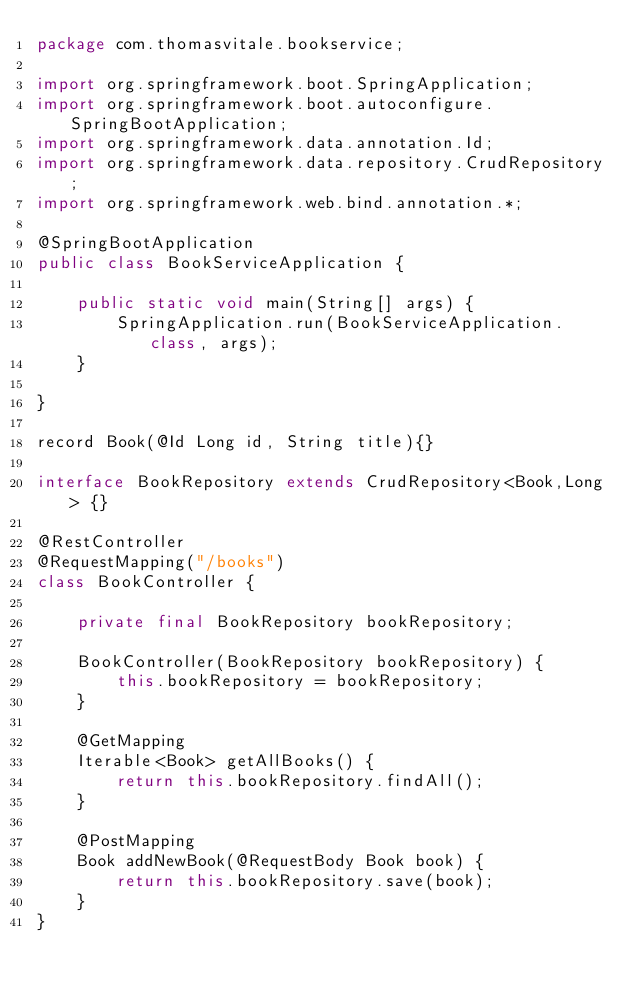<code> <loc_0><loc_0><loc_500><loc_500><_Java_>package com.thomasvitale.bookservice;

import org.springframework.boot.SpringApplication;
import org.springframework.boot.autoconfigure.SpringBootApplication;
import org.springframework.data.annotation.Id;
import org.springframework.data.repository.CrudRepository;
import org.springframework.web.bind.annotation.*;

@SpringBootApplication
public class BookServiceApplication {

    public static void main(String[] args) {
        SpringApplication.run(BookServiceApplication.class, args);
    }

}

record Book(@Id Long id, String title){}

interface BookRepository extends CrudRepository<Book,Long> {}

@RestController
@RequestMapping("/books")
class BookController {

    private final BookRepository bookRepository;

    BookController(BookRepository bookRepository) {
        this.bookRepository = bookRepository;
    }

    @GetMapping
    Iterable<Book> getAllBooks() {
        return this.bookRepository.findAll();
    }

    @PostMapping
    Book addNewBook(@RequestBody Book book) {
        return this.bookRepository.save(book);
    }
}
</code> 